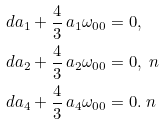<formula> <loc_0><loc_0><loc_500><loc_500>d a _ { 1 } + \frac { 4 } { 3 } \, a _ { 1 } \omega _ { 0 0 } & = 0 , \\ d a _ { 2 } + \frac { 4 } { 3 } \, a _ { 2 } \omega _ { 0 0 } & = 0 , \ n \\ d a _ { 4 } + \frac { 4 } { 3 } \, a _ { 4 } \omega _ { 0 0 } & = 0 . \ n</formula> 